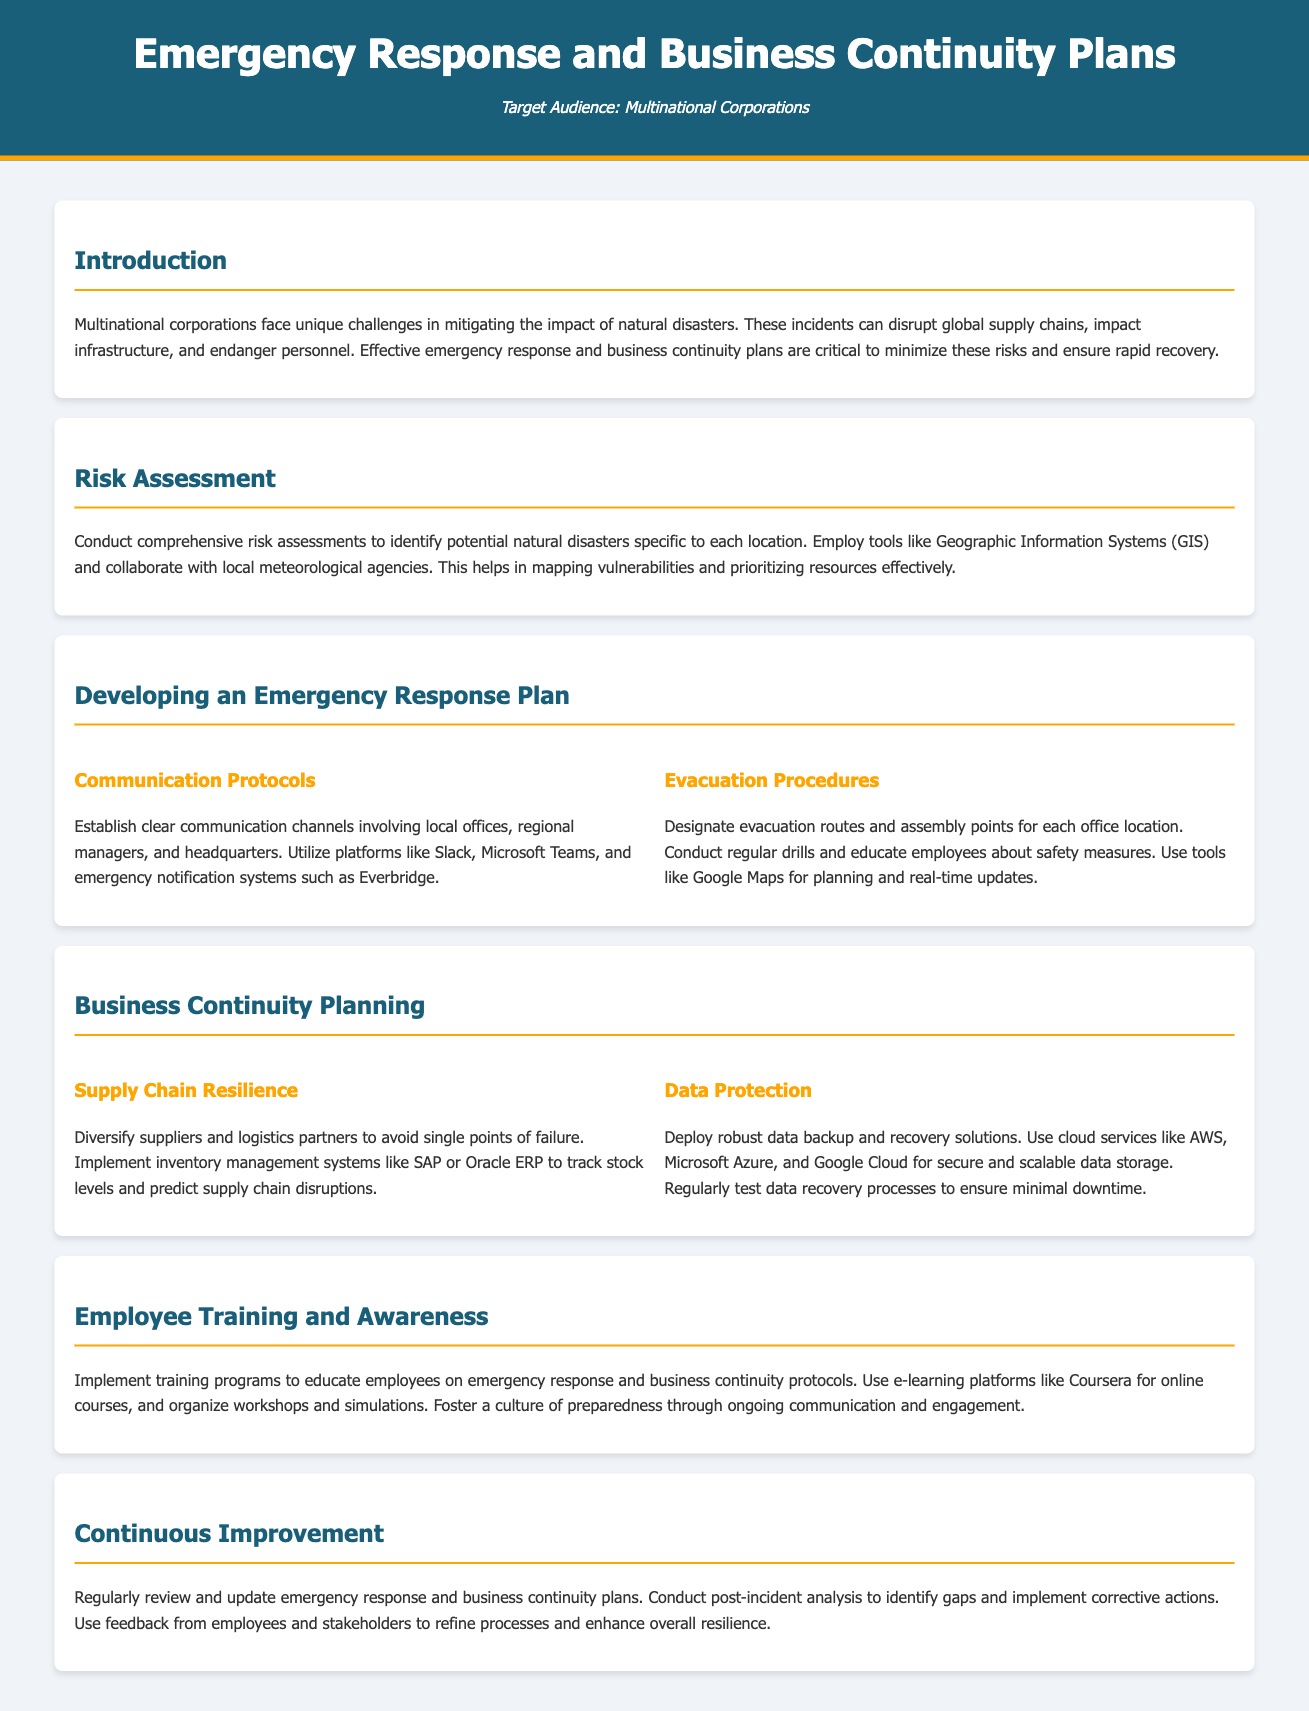What is the target audience of the document? The target audience is specified in the header section of the document.
Answer: Multinational Corporations What tools are recommended for risk assessment? The document suggests using Geographic Information Systems and collaboration with local meteorological agencies for risk assessment.
Answer: Geographic Information Systems (GIS) What are two platforms mentioned for communication protocols? The document lists specific platforms under the communication protocols section.
Answer: Slack, Microsoft Teams What should be diversified to enhance supply chain resilience? The business continuity planning section emphasizes avoiding single points of failure.
Answer: Suppliers and logistics partners What is a key aspect of data protection mentioned? The data protection section outlines robust solutions for data handling.
Answer: Backup and recovery solutions How should employee training be conducted according to the document? The employee training and awareness section describes how employees can be educated about protocols.
Answer: Training programs What is emphasized in the continuous improvement section? The continuous improvement section focuses on the importance of revisiting plans and learning from incidents.
Answer: Regularly review and update What is the primary purpose of establishing evacuation procedures? The evacuation procedures are outlined to ensure safety in emergency situations.
Answer: Safety of employees 